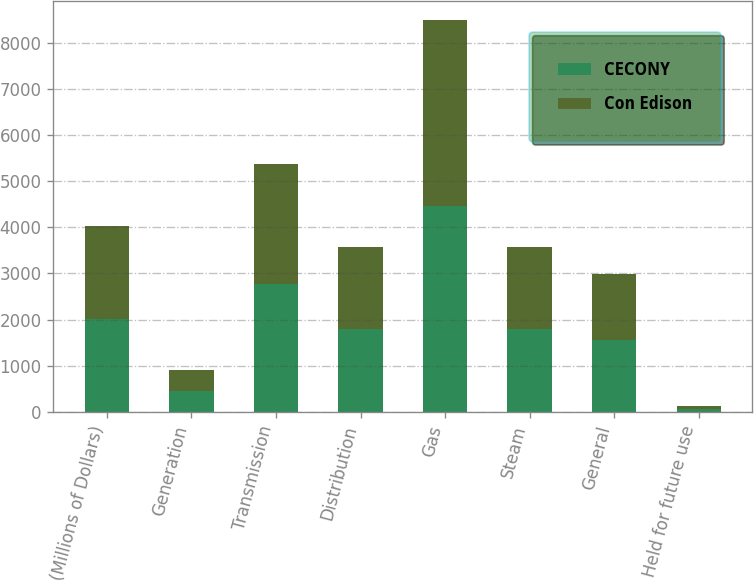Convert chart to OTSL. <chart><loc_0><loc_0><loc_500><loc_500><stacked_bar_chart><ecel><fcel>(Millions of Dollars)<fcel>Generation<fcel>Transmission<fcel>Distribution<fcel>Gas<fcel>Steam<fcel>General<fcel>Held for future use<nl><fcel>CECONY<fcel>2013<fcel>452<fcel>2776<fcel>1790<fcel>4469<fcel>1790<fcel>1565<fcel>73<nl><fcel>Con Edison<fcel>2013<fcel>452<fcel>2597<fcel>1790<fcel>4013<fcel>1790<fcel>1433<fcel>62<nl></chart> 